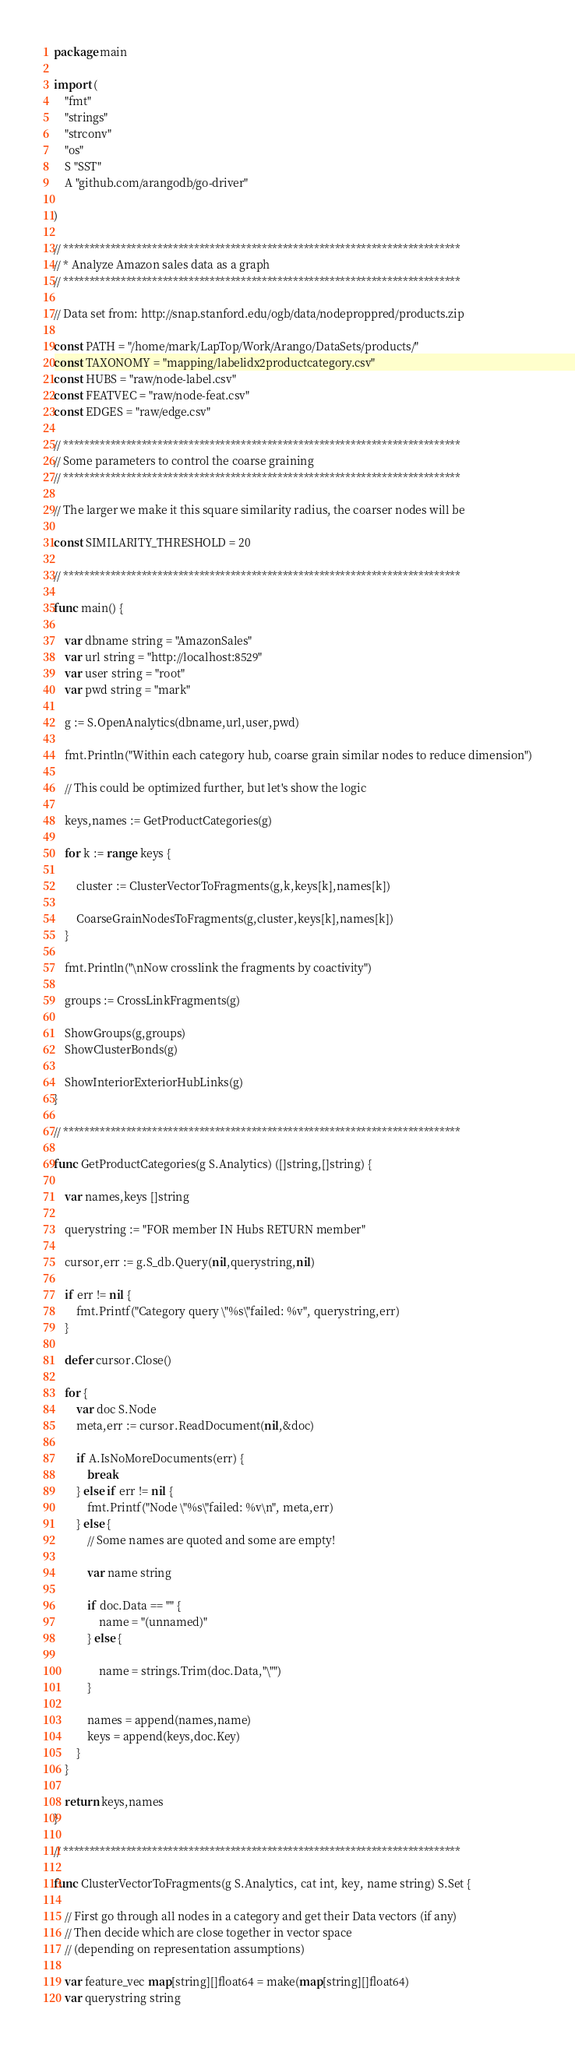Convert code to text. <code><loc_0><loc_0><loc_500><loc_500><_Go_>
package main

import (
	"fmt"
	"strings"
	"strconv"
	"os"
	S "SST"
	A "github.com/arangodb/go-driver"

)

// ****************************************************************************
// * Analyze Amazon sales data as a graph
// ****************************************************************************

// Data set from: http://snap.stanford.edu/ogb/data/nodeproppred/products.zip

const PATH = "/home/mark/LapTop/Work/Arango/DataSets/products/"
const TAXONOMY = "mapping/labelidx2productcategory.csv"
const HUBS = "raw/node-label.csv"
const FEATVEC = "raw/node-feat.csv"
const EDGES = "raw/edge.csv"

// ****************************************************************************
// Some parameters to control the coarse graining
// ****************************************************************************

// The larger we make it this square similarity radius, the coarser nodes will be

const SIMILARITY_THRESHOLD = 20

// ****************************************************************************

func main() {

	var dbname string = "AmazonSales"
	var url string = "http://localhost:8529"
	var user string = "root"
	var pwd string = "mark"

	g := S.OpenAnalytics(dbname,url,user,pwd)

	fmt.Println("Within each category hub, coarse grain similar nodes to reduce dimension")
 
	// This could be optimized further, but let's show the logic

	keys,names := GetProductCategories(g)

	for k := range keys {

		cluster := ClusterVectorToFragments(g,k,keys[k],names[k])

		CoarseGrainNodesToFragments(g,cluster,keys[k],names[k])
	}

	fmt.Println("\nNow crosslink the fragments by coactivity")

	groups := CrossLinkFragments(g)

	ShowGroups(g,groups)
	ShowClusterBonds(g)

	ShowInteriorExteriorHubLinks(g)
}

// ****************************************************************************

func GetProductCategories(g S.Analytics) ([]string,[]string) {

	var names,keys []string

	querystring := "FOR member IN Hubs RETURN member"

	cursor,err := g.S_db.Query(nil,querystring,nil)

	if err != nil {
		fmt.Printf("Category query \"%s\"failed: %v", querystring,err)
	}

	defer cursor.Close()

	for {
		var doc S.Node
		meta,err := cursor.ReadDocument(nil,&doc)

		if A.IsNoMoreDocuments(err) {
			break
		} else if err != nil {
			fmt.Printf("Node \"%s\"failed: %v\n", meta,err)
		} else {
			// Some names are quoted and some are empty!

			var name string

			if doc.Data == "" {
				name = "(unnamed)"
			} else {

				name = strings.Trim(doc.Data,"\"")
			}

			names = append(names,name)
			keys = append(keys,doc.Key)
		}
	}

	return keys,names
}

// ****************************************************************************

func ClusterVectorToFragments(g S.Analytics, cat int, key, name string) S.Set {

	// First go through all nodes in a category and get their Data vectors (if any)
	// Then decide which are close together in vector space 
	// (depending on representation assumptions)

	var feature_vec map[string][]float64 = make(map[string][]float64)
	var querystring string
</code> 